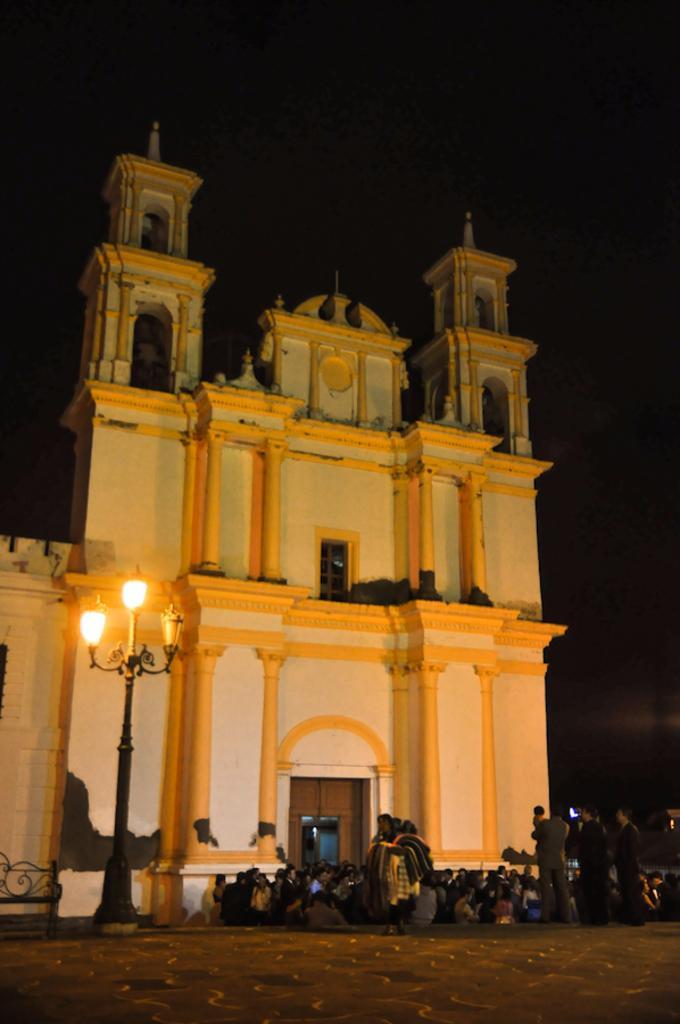Please provide a concise description of this image. In this picture we can see a building, there are some people standing here, on the left side there is a pole and lights, we can see the sky at the top of the picture. 